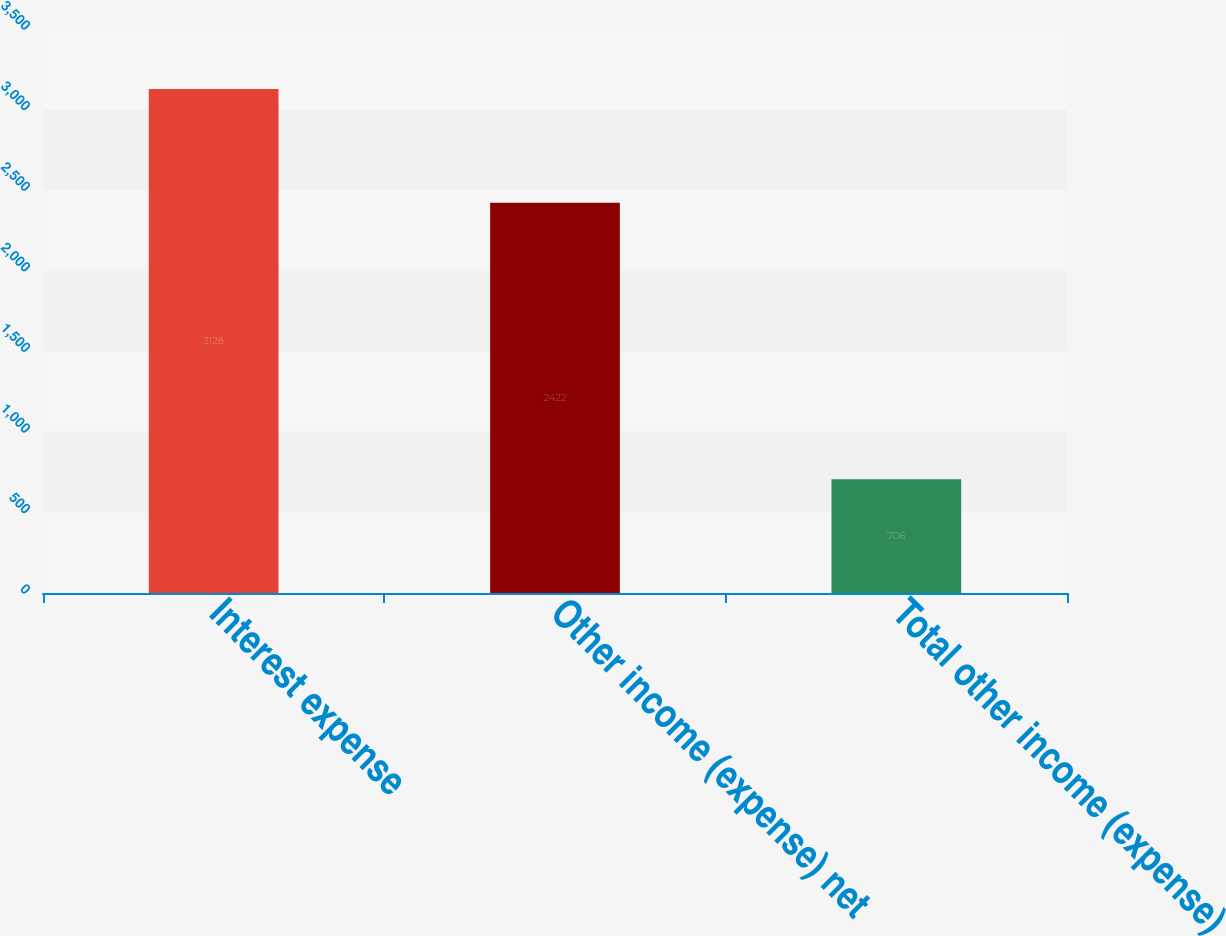<chart> <loc_0><loc_0><loc_500><loc_500><bar_chart><fcel>Interest expense<fcel>Other income (expense) net<fcel>Total other income (expense)<nl><fcel>3128<fcel>2422<fcel>706<nl></chart> 